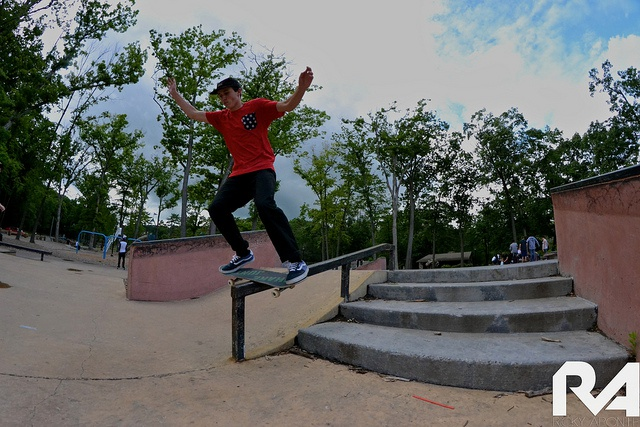Describe the objects in this image and their specific colors. I can see people in lavender, black, maroon, gray, and brown tones, skateboard in lavender, gray, blue, black, and darkblue tones, people in lavender, black, and gray tones, people in lavender, black, and gray tones, and people in lavender, gray, black, navy, and darkblue tones in this image. 